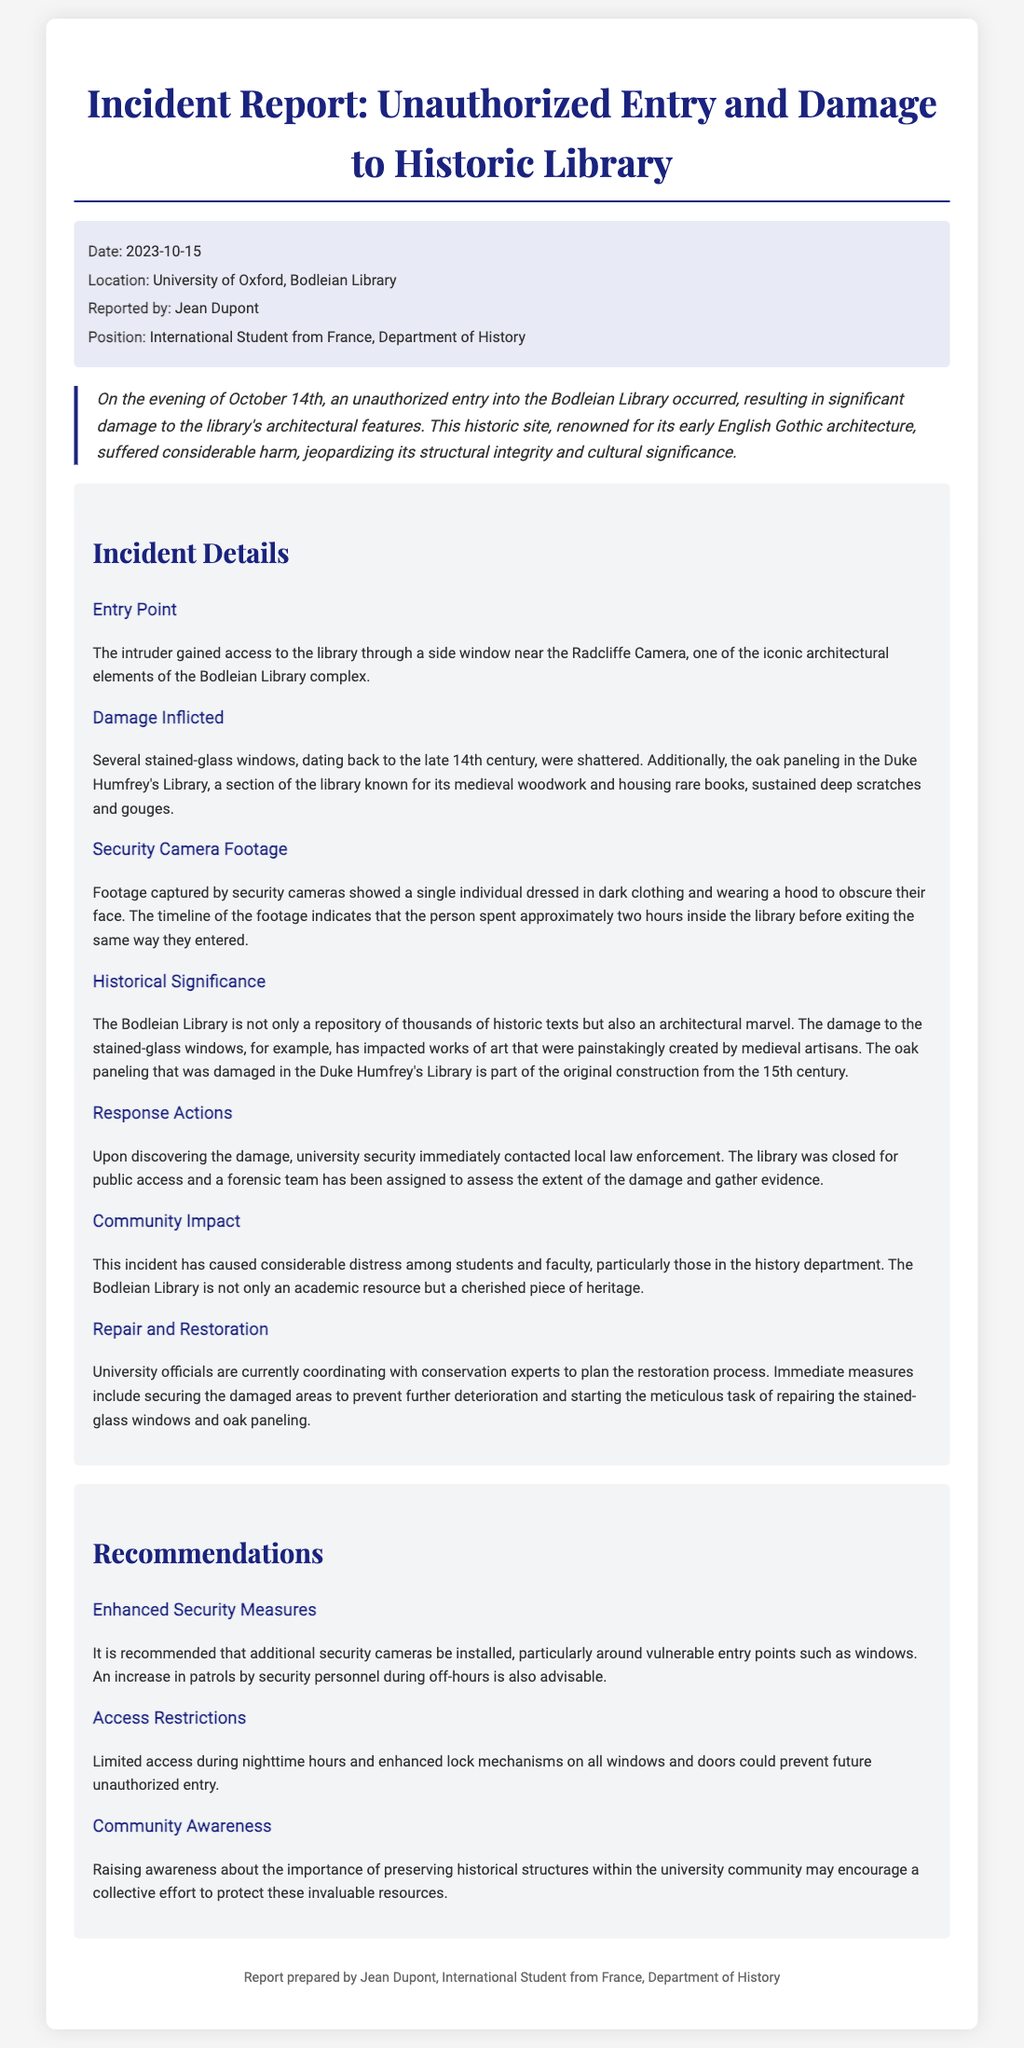what is the date of the incident? The date of the incident is mentioned clearly in the report as October 14th, 2023.
Answer: October 14th what is the name of the library where the incident occurred? The library mentioned in the report is identified as the Bodleian Library, a historic site at the University of Oxford.
Answer: Bodleian Library how many stained-glass windows were reported damaged? The report states that several stained-glass windows were shattered, but doesn't provide an exact number.
Answer: Several who reported the incident? The report specifies that the incident was reported by Jean Dupont, who is an international student from France.
Answer: Jean Dupont what architectural style is the Bodleian Library known for? The Bodleian Library is noted in the report for its early English Gothic architecture.
Answer: Early English Gothic what actions were taken upon discovering the damage? The report indicates that university security immediately contacted local law enforcement after discovering the damage.
Answer: Contacted local law enforcement how long did the intruder spend inside the library? According to security camera footage, the intruder spent approximately two hours inside the library before exiting.
Answer: Two hours what measures are suggested to enhance security? The report recommends installing additional security cameras and increasing patrols by security personnel during off-hours.
Answer: Additional security cameras what community impact did the incident have? The incident caused considerable distress among students and faculty, particularly in the history department.
Answer: Distress among students and faculty 